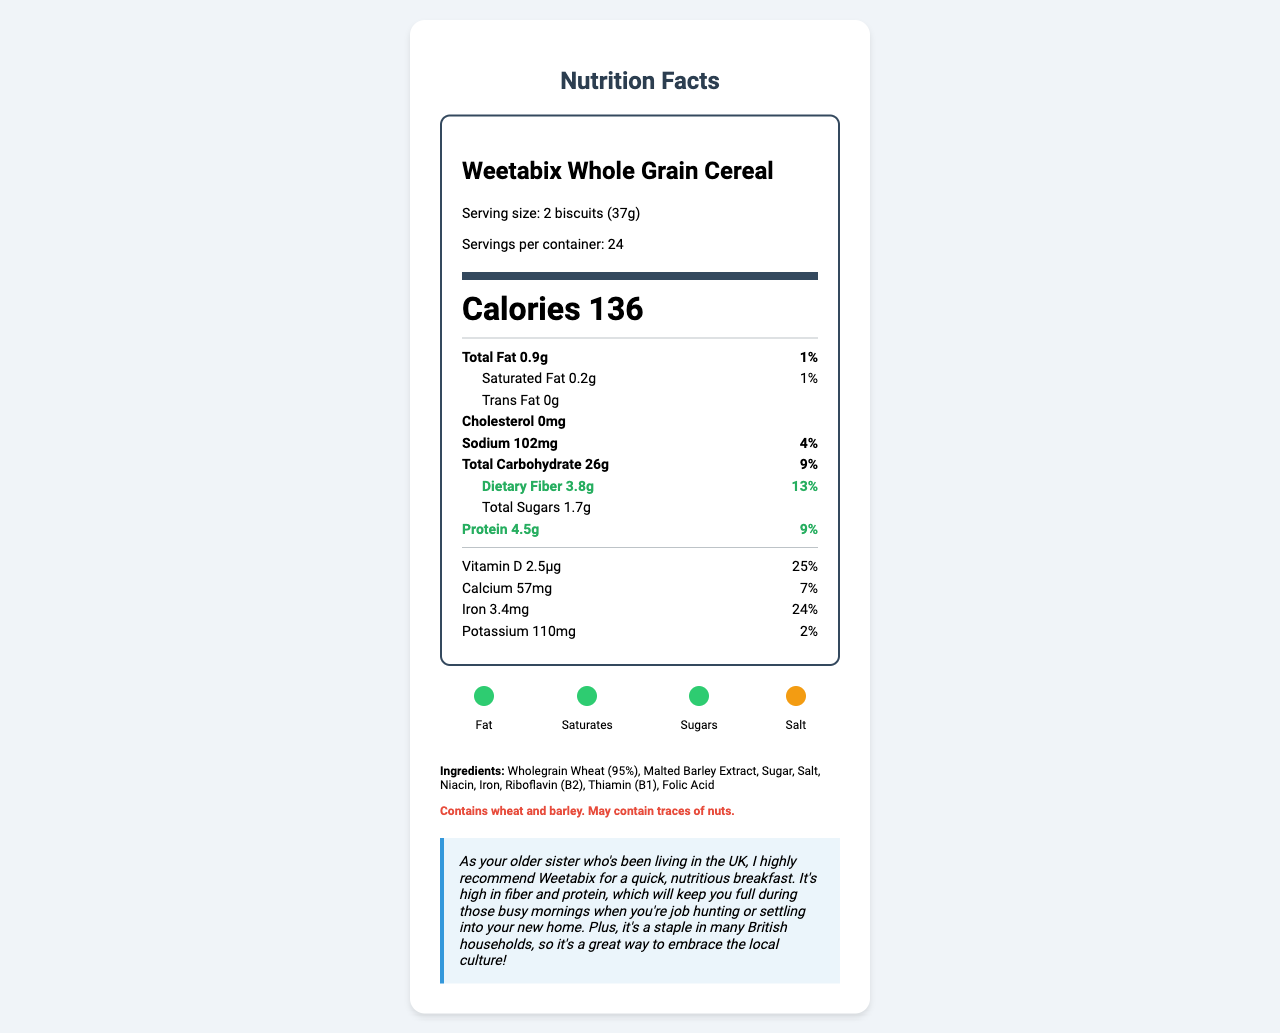What is the serving size of Weetabix Whole Grain Cereal? The serving size is clearly stated as "2 biscuits (37g)" in the document.
Answer: 2 biscuits (37g) How many grams of dietary fiber does each serving contain? The document lists "Dietary Fiber 3.8g" under the nutrients section.
Answer: 3.8g What percentage of the daily value for protein does one serving provide? The document shows "Protein 4.5g" and "9%" next to it, indicating the percent daily value.
Answer: 9% How many calories are there in one serving? The document prominently displays "Calories 136" in the nutrition facts label.
Answer: 136 What are the main ingredients in Weetabix Whole Grain Cereal? The ingredients are listed at the end of the document.
Answer: Wholegrain Wheat (95%), Malted Barley Extract, Sugar, Salt, Niacin, Iron, Riboflavin (B2), Thiamin (B1), Folic Acid Which traffic light label has an amber color? A. Fat B. Saturates C. Sugars D. Salt The traffic light label section shows that the circle for salt is amber, while the others are green.
Answer: D. Salt What is the amount of niacin per serving? The document lists "Niacin 3.1mg" in the nutritional information.
Answer: 3.1mg True or False: Weetabix Whole Grain Cereal contains trans fat. The document states "Trans Fat 0g", indicating no trans fat in the product.
Answer: False What is the percent daily value of iron provided by one serving? The document lists "Iron 3.4mg" and "24%" next to it in the nutrition facts.
Answer: 24% How should Weetabix Whole Grain Cereal be stored after opening? The storage instructions in the document say, "Once opened, store in an airtight container."
Answer: Store in an airtight container Who is the manufacturer of this cereal? The manufacturer details are listed towards the end of the document.
Answer: Weetabix Limited, Burton Latimer, Kettering, Northamptonshire, NN15 5JR Describe the main nutritional highlights and important notes provided in the document. The document focuses on providing detailed nutritional information, storage instructions, and manufacturer details about Weetabix Whole Grain Cereal. It includes specific figures for various nutrients and emphasizes the product's health benefits and cultural significance.
Answer: The document details the nutrition facts for Weetabix Whole Grain Cereal. Each serving (2 biscuits or 37g) contains 136 calories, 3.8g of dietary fiber, and 4.5g of protein. The label also highlights that the cereal has low amounts of fat, saturated fat, and sugars. It includes various vitamins and minerals such as Vitamin D, Calcium, Iron, Niacin, Thiamin, Riboflavin, and Folate. There's a specific emphasis on the high fiber and protein content, making it a nutritious breakfast option. Additionally, the product uses a traffic light label system to indicate low levels of fat, saturates, and sugars, with amber for salt. The cereal must be stored in an airtight container once opened and the manufacturer is Weetabix Limited. My sister's advice highlights the cereal's benefits for busy mornings, due to its high fiber and protein content. How many trace allergens are mentioned? The document mentions that the product may contain traces of nuts.
Answer: May contain traces of nuts. What is the price of a box of Weetabix Whole Grain Cereal? The document does not provide any information regarding the price of the cereal.
Answer: Not enough information 